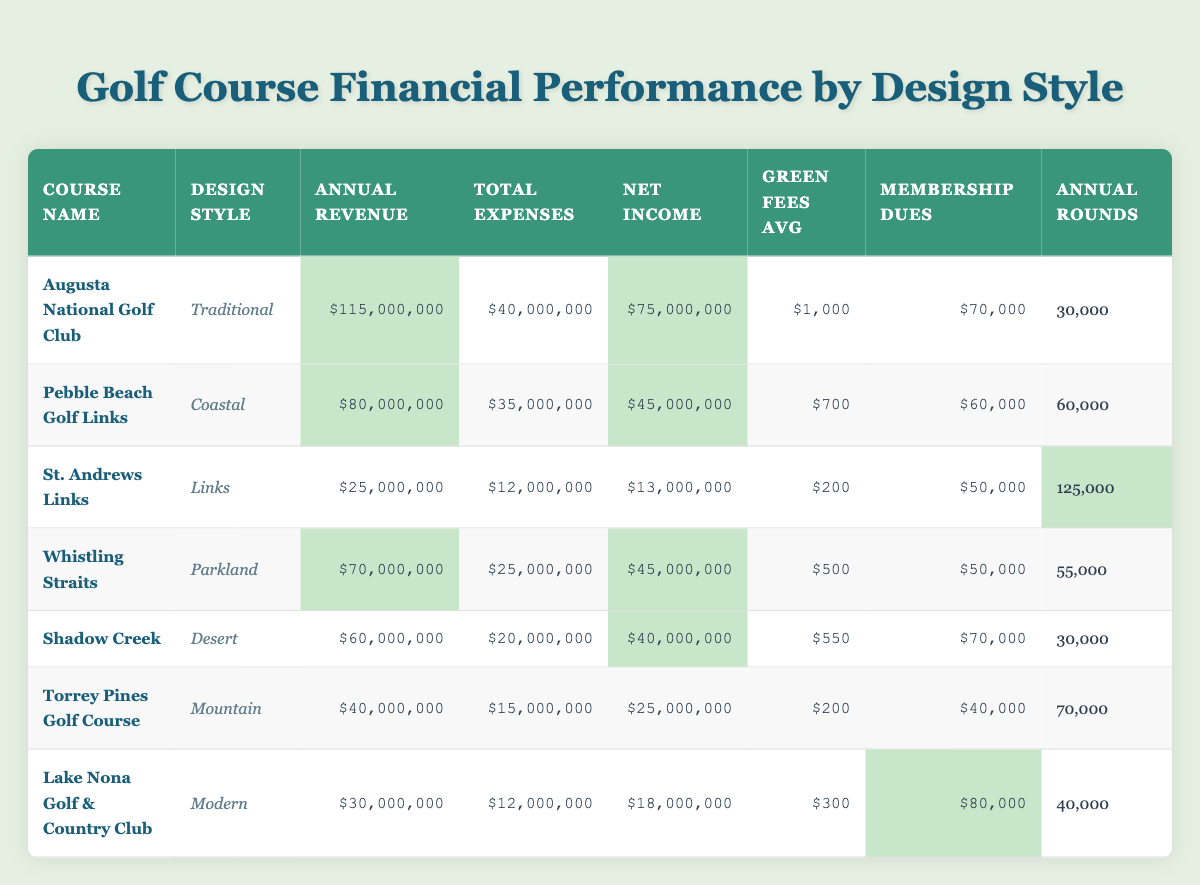What is the net income of Augusta National Golf Club? The net income for Augusta National Golf Club is listed in the table as $75,000,000.
Answer: $75,000,000 Which golf course has the highest annual revenue? By comparing the annual revenue values of all courses listed, Augusta National Golf Club shows the highest revenue at $115,000,000.
Answer: Augusta National Golf Club What is the average green fee across all courses? The green fees of all courses are $1,000, $700, $200, $500, $550, $200, and $300. Summing these gives $1,000 + $700 + $200 + $500 + $550 + $200 + $300 = $3,450. There are 7 courses, so the average is $3,450 / 7 = approximately $492.86.
Answer: $492.86 Does Lake Nona Golf & Country Club have more annual rounds played than Torrey Pines Golf Course? Lake Nona Golf & Country Club has 40,000 rounds played, while Torrey Pines Golf Course has 70,000. Since 40,000 is less than 70,000, the answer is no.
Answer: No Which design style has the least annual revenue? Comparing the annual revenues of all design styles in the table, St. Andrews Links has the least with $25,000,000.
Answer: Links What is the total net income for all courses combined? Adding the net incomes of all courses gives $75,000,000 (Augusta) + $45,000,000 (Pebble Beach) + $13,000,000 (St. Andrews) + $45,000,000 (Whistling Straits) + $40,000,000 (Shadow Creek) + $25,000,000 (Torrey Pines) + $18,000,000 (Lake Nona) = $261,000,000.
Answer: $261,000,000 Is the average membership dues for the courses over $50,000? The membership dues are $70,000, $60,000, $50,000, $50,000, $70,000, $40,000, and $80,000. The sum is $70,000 + $60,000 + $50,000 + $50,000 + $70,000 + $40,000 + $80,000 = $420,000. Dividing by 7 gives an average of $420,000 / 7 = $60,000, which is over $50,000.
Answer: Yes Which course type has the lowest average green fee? The green fees for courses are $1,000 (Traditional), $700 (Coastal), $200 (Links), $500 (Parkland), $550 (Desert), $200 (Mountain), and $300 (Modern). The lowest value is $200, associated with St. Andrews Links and Torrey Pines Golf Course.
Answer: Links and Mountain What is the total annual expenses for courses with a coastal design style? Only Pebble Beach Golf Links falls under coastal design style with total expenses of $35,000,000. So, the total annual expenses for coastal design is just $35,000,000.
Answer: $35,000,000 If you were to rank the courses by net income, which course would be in the second position? The courses ranked by net income are: Augusta National Golf Club ($75,000,000), Pebble Beach Golf Links ($45,000,000), Whistling Straits ($45,000,000), Shadow Creek ($40,000,000), Torrey Pines ($25,000,000), Lake Nona ($18,000,000), St. Andrews ($13,000,000). Pebble Beach and Whistling Straits both have the second highest, but since Pebble Beach is first alphabetically, it is deemed second position.
Answer: Pebble Beach Golf Links 